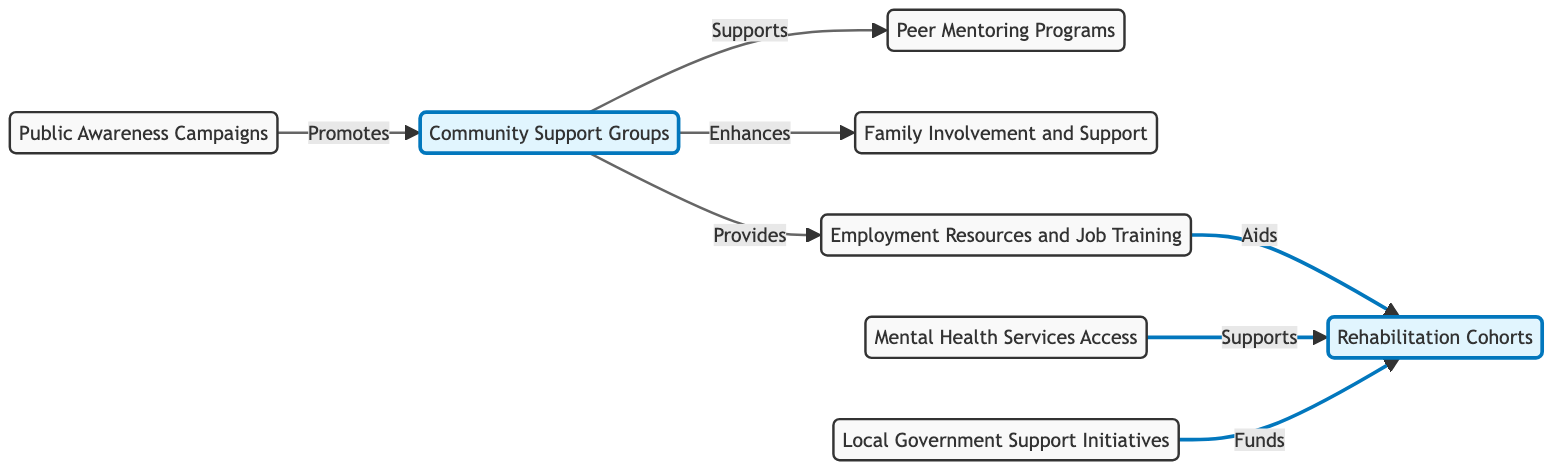What is the main role of Community Support Groups? According to the diagram, Community Support Groups support Peer Mentoring, enhance Family Involvement, and provide Employment Resources. Therefore, their main role is to function as a foundational element that connects various supportive actions for individuals in rehabilitation.
Answer: foundational element How many nodes are present in the diagram? By counting the distinct categories represented in the diagram, we find a total of 8 nodes: Community Support Groups, Peer Mentoring Programs, Family Involvement and Support, Employment Resources and Job Training, Mental Health Services Access, Rehabilitation Cohorts, Public Awareness Campaigns, and Local Government Support Initiatives.
Answer: 8 Which node does Local Government Support directly connect to? The diagram shows that Local Government Support connects directly to Rehabilitation Cohorts, indicating that it plays a direct role in funding these cohorts.
Answer: Rehabilitation Cohorts What are the three types of support provided by Community Support Groups? Community Support Groups provide support to Peer Mentoring, enhance Family Involvement, and offer Employment Resources, indicating a comprehensive support structure.
Answer: Peer Mentoring, Family Involvement, Employment Resources What do Public Awareness Campaigns promote? The diagram indicates that Public Awareness Campaigns promote Community Support Groups, showing their role in raising awareness about these vital support networks.
Answer: Community Support Groups Which two nodes lead directly to Rehabilitation Cohorts? Analyzing the directed edges, we find that Employment Resources and Mental Health Services both lead directly to Rehabilitation Cohorts, which are crucial for providing necessary support to individuals in rehabilitation.
Answer: Employment Resources, Mental Health Services How do Employment Resources and Mental Health Services relate in the context of Rehabilitation Cohorts? Employment Resources and Mental Health Services both point to Rehabilitation Cohorts, highlighting that these resources are integral components that work together to aid in the rehabilitation process.
Answer: integral components Which node is the starting point for connections to both Peer Mentoring Programs and Family Involvement? The diagram shows that Community Support Groups is the node that connects directly to both Peer Mentoring Programs and Family Involvement, acting as a central hub for these support relationships.
Answer: Community Support Groups 